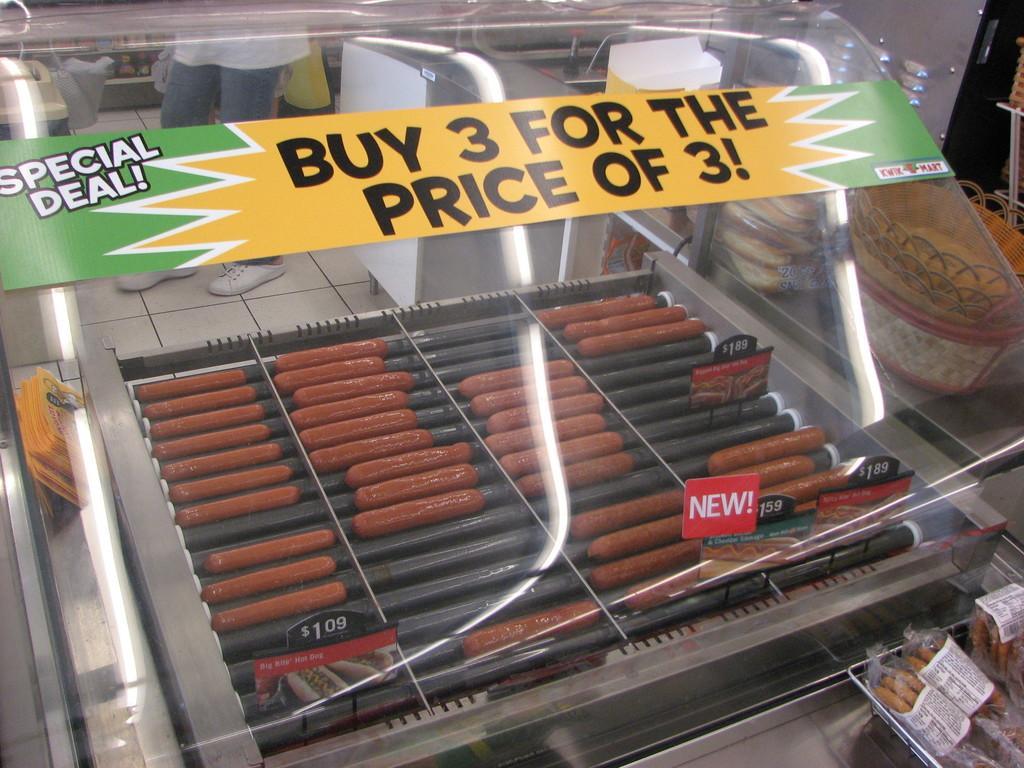How would you summarize this image in a sentence or two? In this picture we can see sausages, price boards, poster, cards, baskets, food items and in the background we can see some people standing on the floor and some objects. 